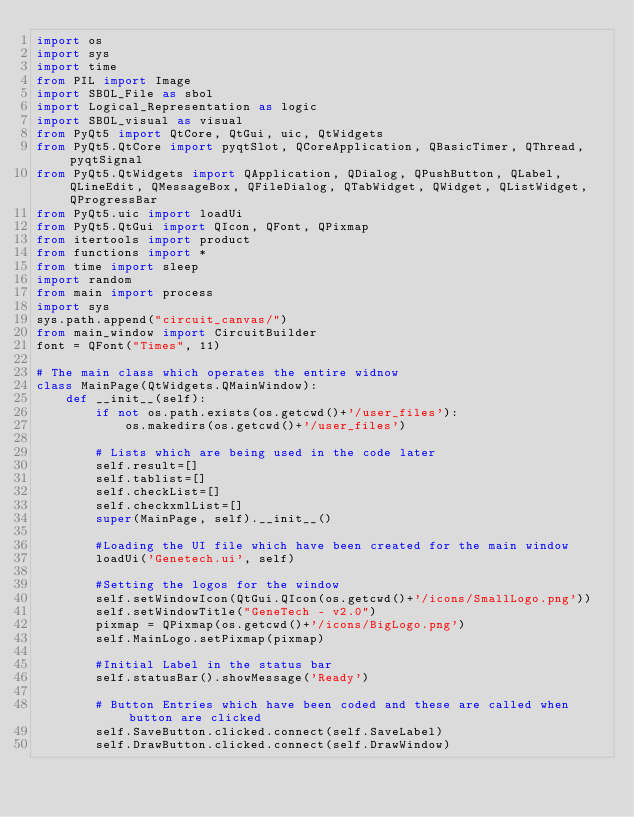Convert code to text. <code><loc_0><loc_0><loc_500><loc_500><_Python_>import os
import sys
import time
from PIL import Image
import SBOL_File as sbol
import Logical_Representation as logic
import SBOL_visual as visual
from PyQt5 import QtCore, QtGui, uic, QtWidgets
from PyQt5.QtCore import pyqtSlot, QCoreApplication, QBasicTimer, QThread, pyqtSignal
from PyQt5.QtWidgets import QApplication, QDialog, QPushButton, QLabel, QLineEdit, QMessageBox, QFileDialog, QTabWidget, QWidget, QListWidget, QProgressBar
from PyQt5.uic import loadUi
from PyQt5.QtGui import QIcon, QFont, QPixmap
from itertools import product
from functions import *
from time import sleep
import random
from main import process
import sys
sys.path.append("circuit_canvas/")
from main_window import CircuitBuilder
font = QFont("Times", 11)

# The main class which operates the entire widnow
class MainPage(QtWidgets.QMainWindow):
    def __init__(self):
        if not os.path.exists(os.getcwd()+'/user_files'):
            os.makedirs(os.getcwd()+'/user_files')

        # Lists which are being used in the code later
        self.result=[]
        self.tablist=[]
        self.checkList=[]
        self.checkxmlList=[]
        super(MainPage, self).__init__()

        #Loading the UI file which have been created for the main window
        loadUi('Genetech.ui', self)

        #Setting the logos for the window
        self.setWindowIcon(QtGui.QIcon(os.getcwd()+'/icons/SmallLogo.png'))
        self.setWindowTitle("GeneTech - v2.0")
        pixmap = QPixmap(os.getcwd()+'/icons/BigLogo.png')
        self.MainLogo.setPixmap(pixmap)

        #Initial Label in the status bar
        self.statusBar().showMessage('Ready')

        # Button Entries which have been coded and these are called when button are clicked
        self.SaveButton.clicked.connect(self.SaveLabel)
        self.DrawButton.clicked.connect(self.DrawWindow)
</code> 